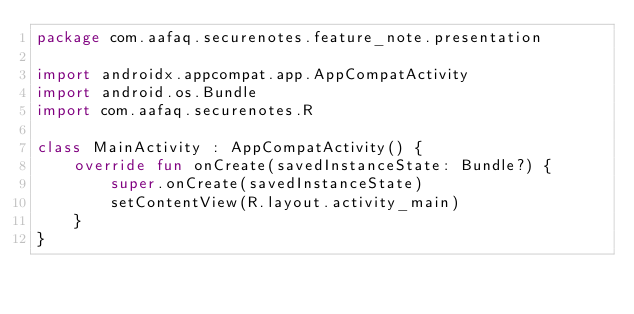<code> <loc_0><loc_0><loc_500><loc_500><_Kotlin_>package com.aafaq.securenotes.feature_note.presentation

import androidx.appcompat.app.AppCompatActivity
import android.os.Bundle
import com.aafaq.securenotes.R

class MainActivity : AppCompatActivity() {
    override fun onCreate(savedInstanceState: Bundle?) {
        super.onCreate(savedInstanceState)
        setContentView(R.layout.activity_main)
    }
}</code> 